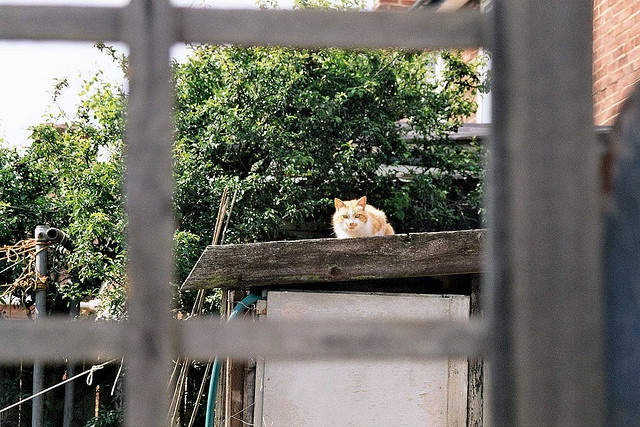Describe the objects in this image and their specific colors. I can see a cat in lavender, white, tan, and black tones in this image. 